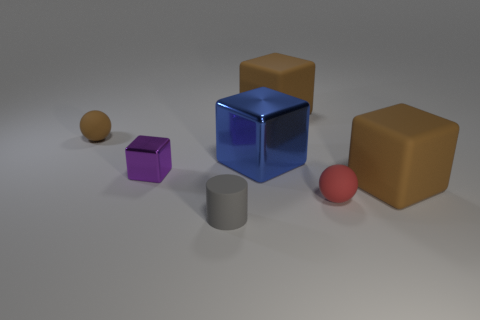What is the shape of the red rubber object that is the same size as the brown rubber ball?
Offer a terse response. Sphere. There is a brown cube that is on the left side of the red ball; is it the same size as the metal object that is on the right side of the matte cylinder?
Your answer should be very brief. Yes. There is a small cylinder that is made of the same material as the red thing; what color is it?
Your answer should be very brief. Gray. Do the big brown cube that is behind the blue shiny object and the small ball in front of the brown ball have the same material?
Your response must be concise. Yes. Are there any other cylinders that have the same size as the rubber cylinder?
Ensure brevity in your answer.  No. What is the size of the rubber block that is to the right of the small sphere to the right of the tiny brown matte sphere?
Ensure brevity in your answer.  Large. What shape is the large blue thing behind the shiny block that is in front of the large blue cube?
Keep it short and to the point. Cube. What number of small gray cylinders have the same material as the gray object?
Keep it short and to the point. 0. There is a cube to the left of the big blue thing; what is its material?
Offer a very short reply. Metal. There is a rubber thing that is behind the tiny ball behind the metallic block right of the small cylinder; what is its shape?
Your answer should be very brief. Cube. 